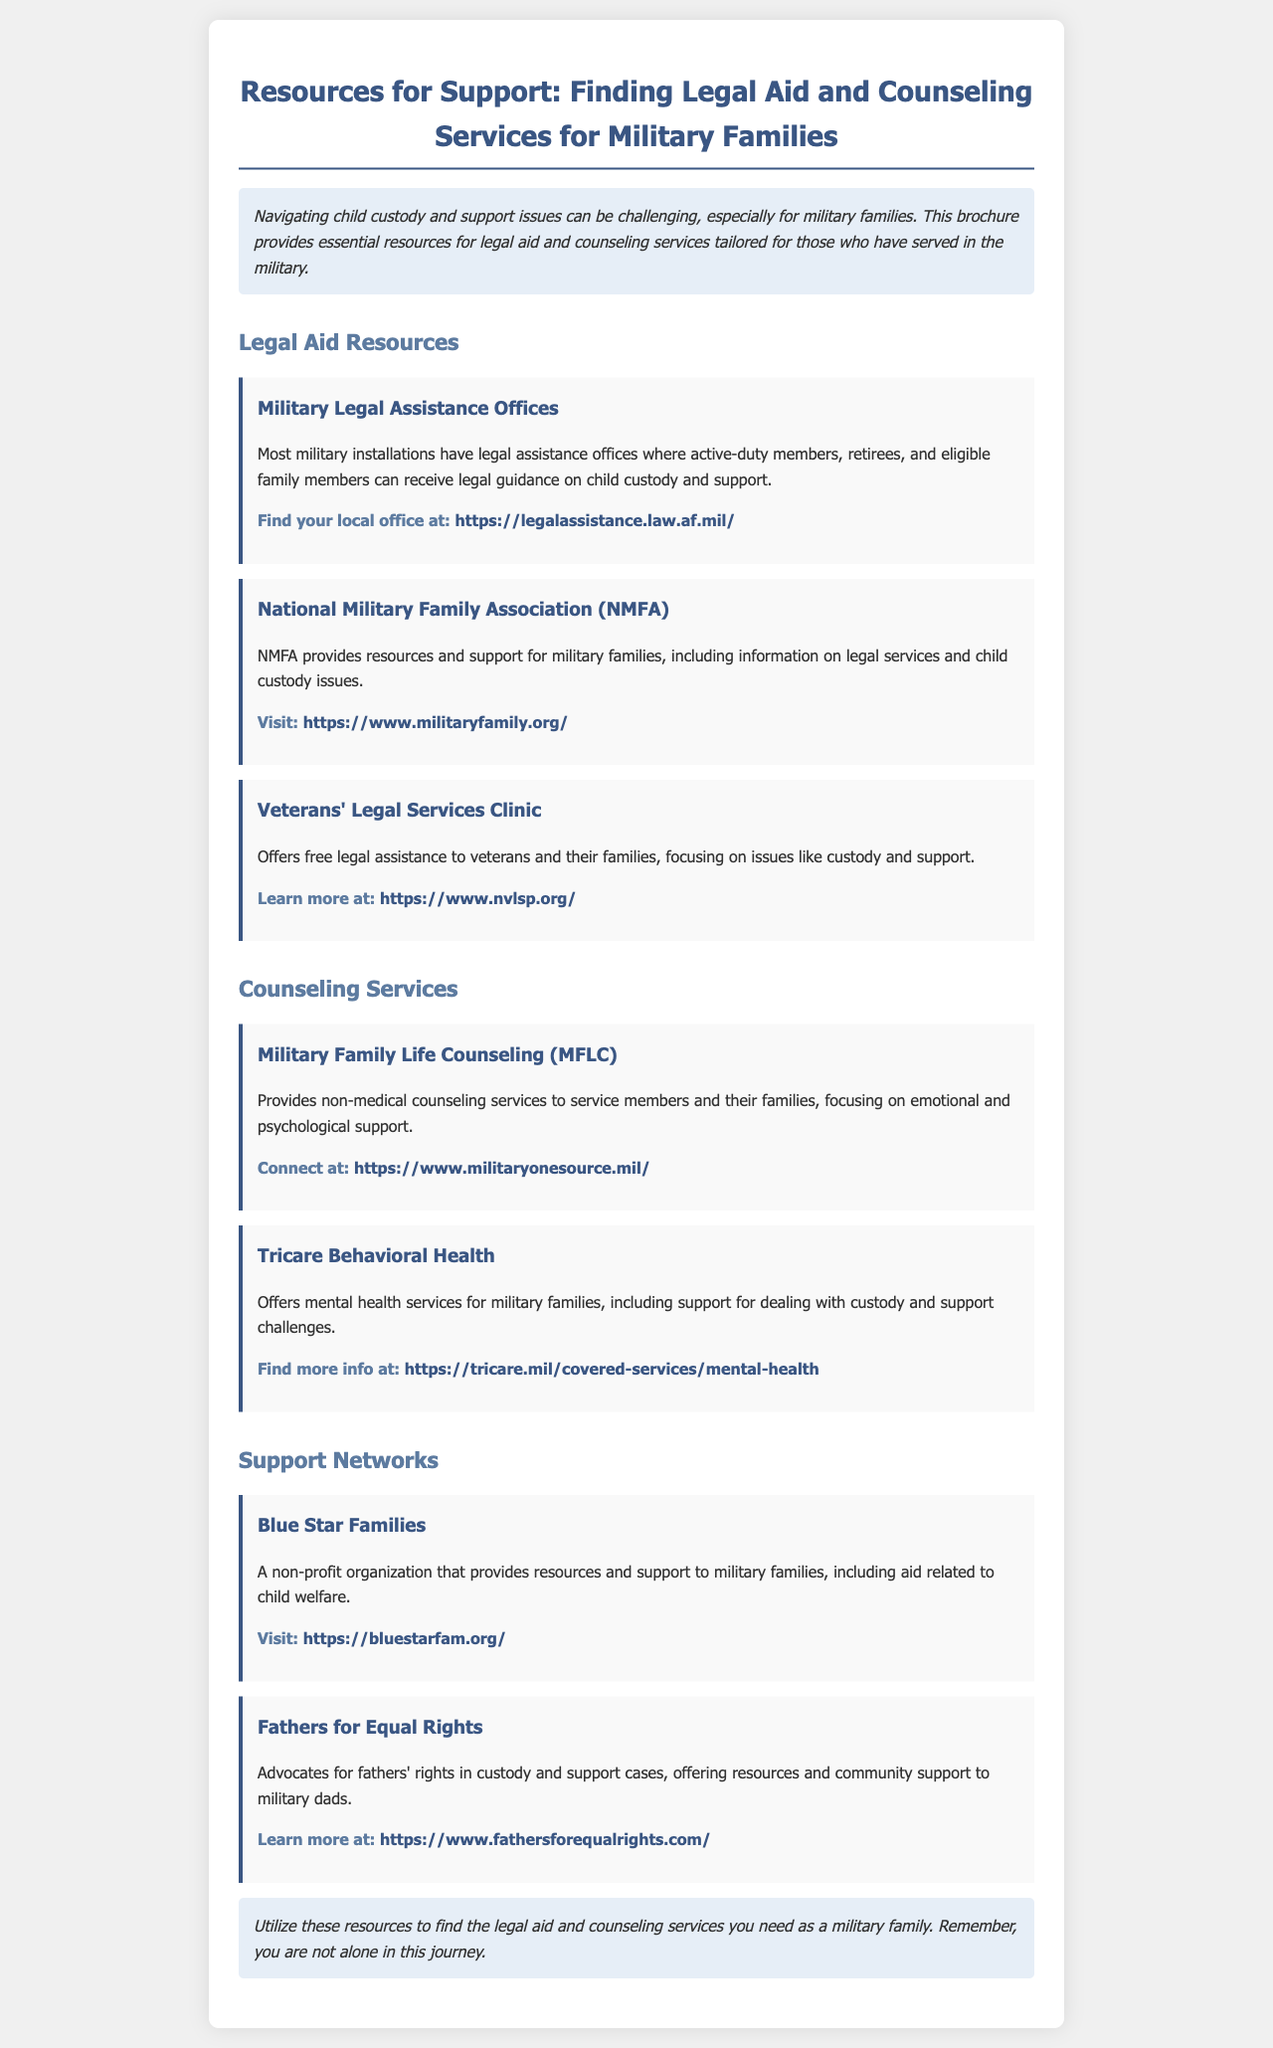What is the title of the brochure? The title is provided at the top of the document as the main heading.
Answer: Resources for Support: Finding Legal Aid and Counseling Services for Military Families What organization provides support for military families regarding legal services? The document lists several organizations, one of which is mentioned specifically in the legal aid section.
Answer: National Military Family Association (NMFA) Where can I find my local Military Legal Assistance Office? The document provides a link to a website that helps locate these offices.
Answer: https://legalassistance.law.af.mil/ What service offers non-medical counseling to military families? The document lists specific counseling services, one of which is named here.
Answer: Military Family Life Counseling (MFLC) Which organization advocates for fathers' rights in custody cases? This organization's role in custody and support advocacy is clearly outlined in the resources section.
Answer: Fathers for Equal Rights What type of assistance does the Veterans' Legal Services Clinic provide? The document states the focus of this clinic's services in relation to veterans and their families.
Answer: Free legal assistance What is the main theme of the conclusion section? The conclusion summarizes the purpose of the document, encouraging utilization of the listed resources.
Answer: Finding legal aid and counseling services What organization focuses on emotional and psychological support for military families? This organization is specifically identified in the counseling services section.
Answer: Tricare Behavioral Health 